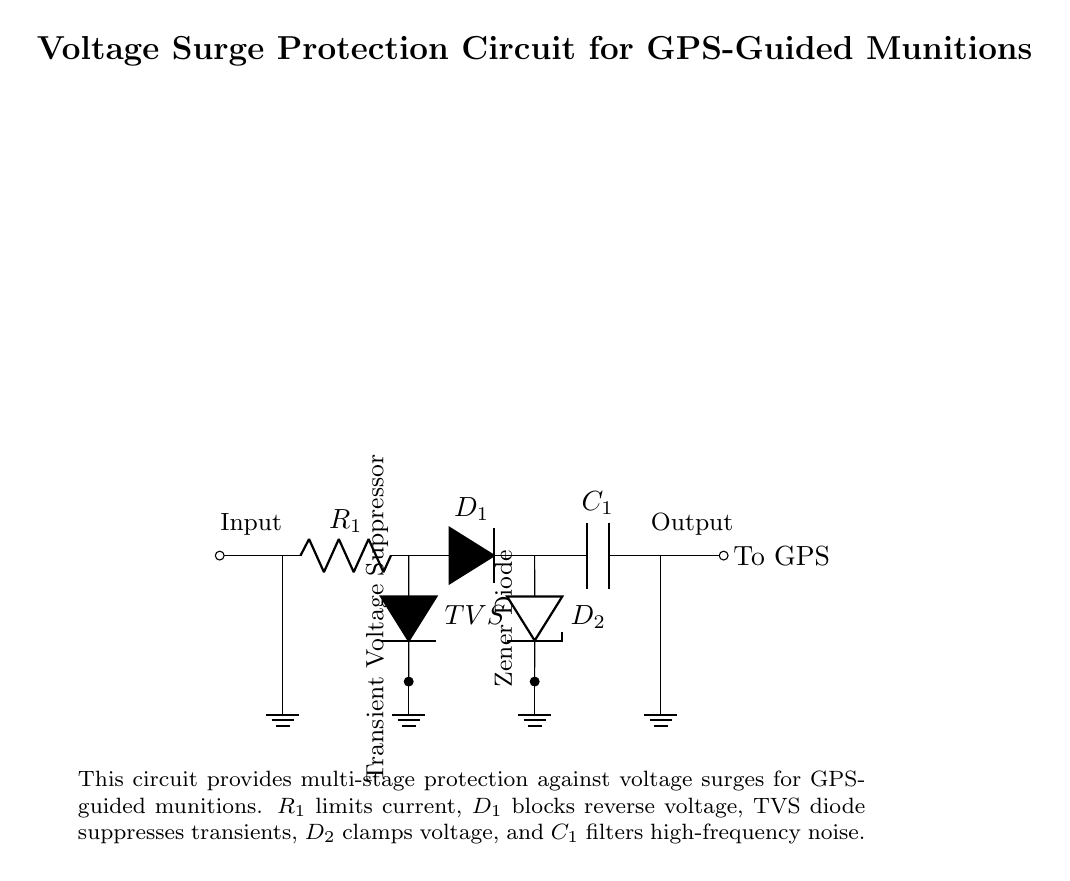What component limits current in the circuit? The component that limits current in the circuit is labeled as R1, which is a resistor. Its position in the circuit indicates its role in controlling the flow of current and preventing excessive current that could lead to damage.
Answer: R1 What does the TVS diode do in this circuit? The TVS (Transient Voltage Suppressor) diode is designed to suppress voltage transients. It is placed in parallel with the load and provides a path for excessive voltage to be diverted, thus protecting the components from voltage spikes.
Answer: Suppresses transients How many diodes are in the circuit? There are two diodes in the circuit: the TVS diode and the Zener diode labeled D1 and D2, respectively. Both diodes have distinct roles in protecting against different types of voltage issues.
Answer: Two Which component filters high-frequency noise? The component that is responsible for filtering high-frequency noise is labeled as C1, which is a capacitor. It smooths out voltage fluctuations that may occur at high frequencies, ensuring stable operation of the circuit.
Answer: C1 What is the purpose of the Zener diode? The purpose of the Zener diode, labeled D2 in the circuit, is to clamp voltage to a specific level. It ensures that the voltage does not exceed its rated value, thereby protecting sensitive components downstream from over-voltage conditions.
Answer: Clamps voltage What is the input connection type for the circuit? The input connection type is shown as a short to the right of the component labeled R1. This indicates a connection point where the input signal enters the circuit. The purpose of this input is to deliver electrical signals from the source to the protection circuit.
Answer: Short 